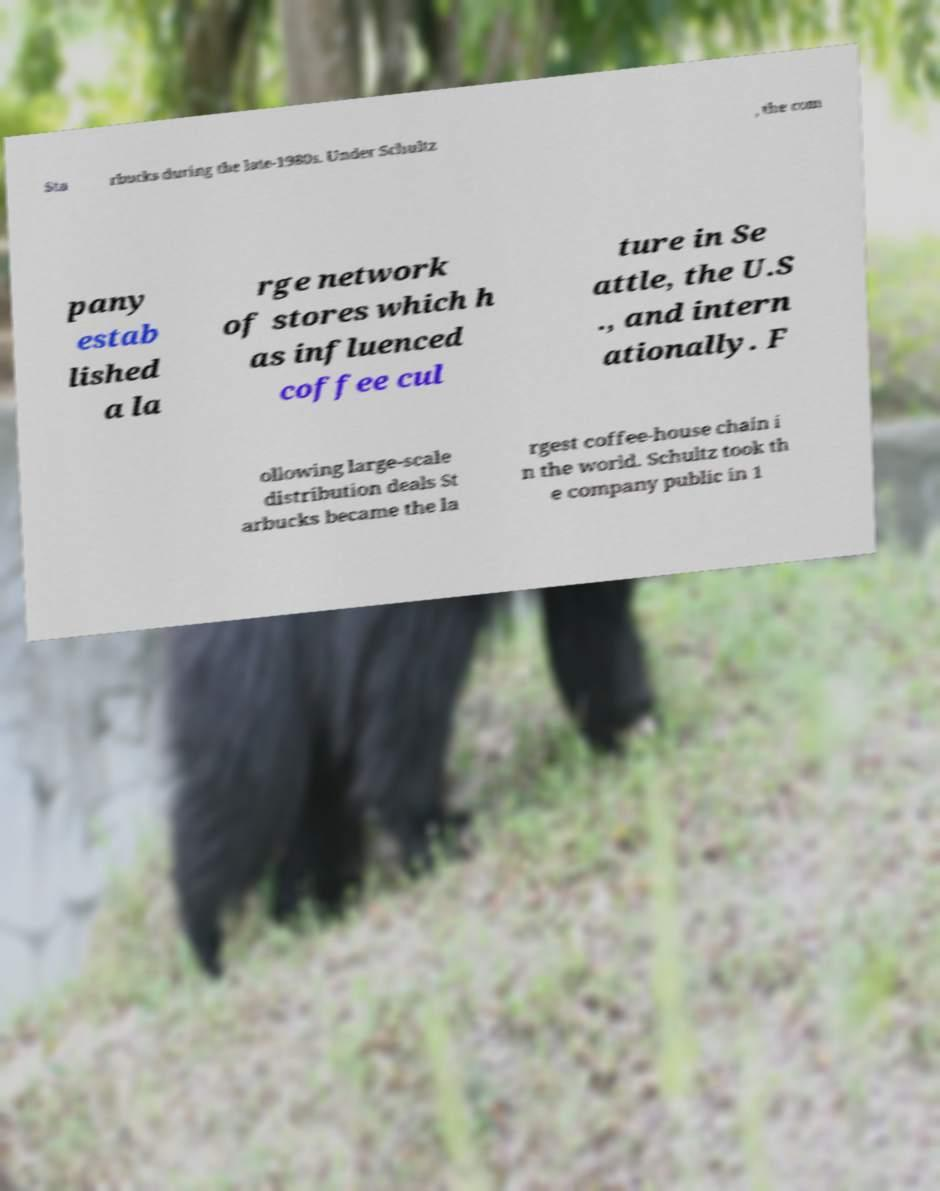Please read and relay the text visible in this image. What does it say? Sta rbucks during the late-1980s. Under Schultz , the com pany estab lished a la rge network of stores which h as influenced coffee cul ture in Se attle, the U.S ., and intern ationally. F ollowing large-scale distribution deals St arbucks became the la rgest coffee-house chain i n the world. Schultz took th e company public in 1 